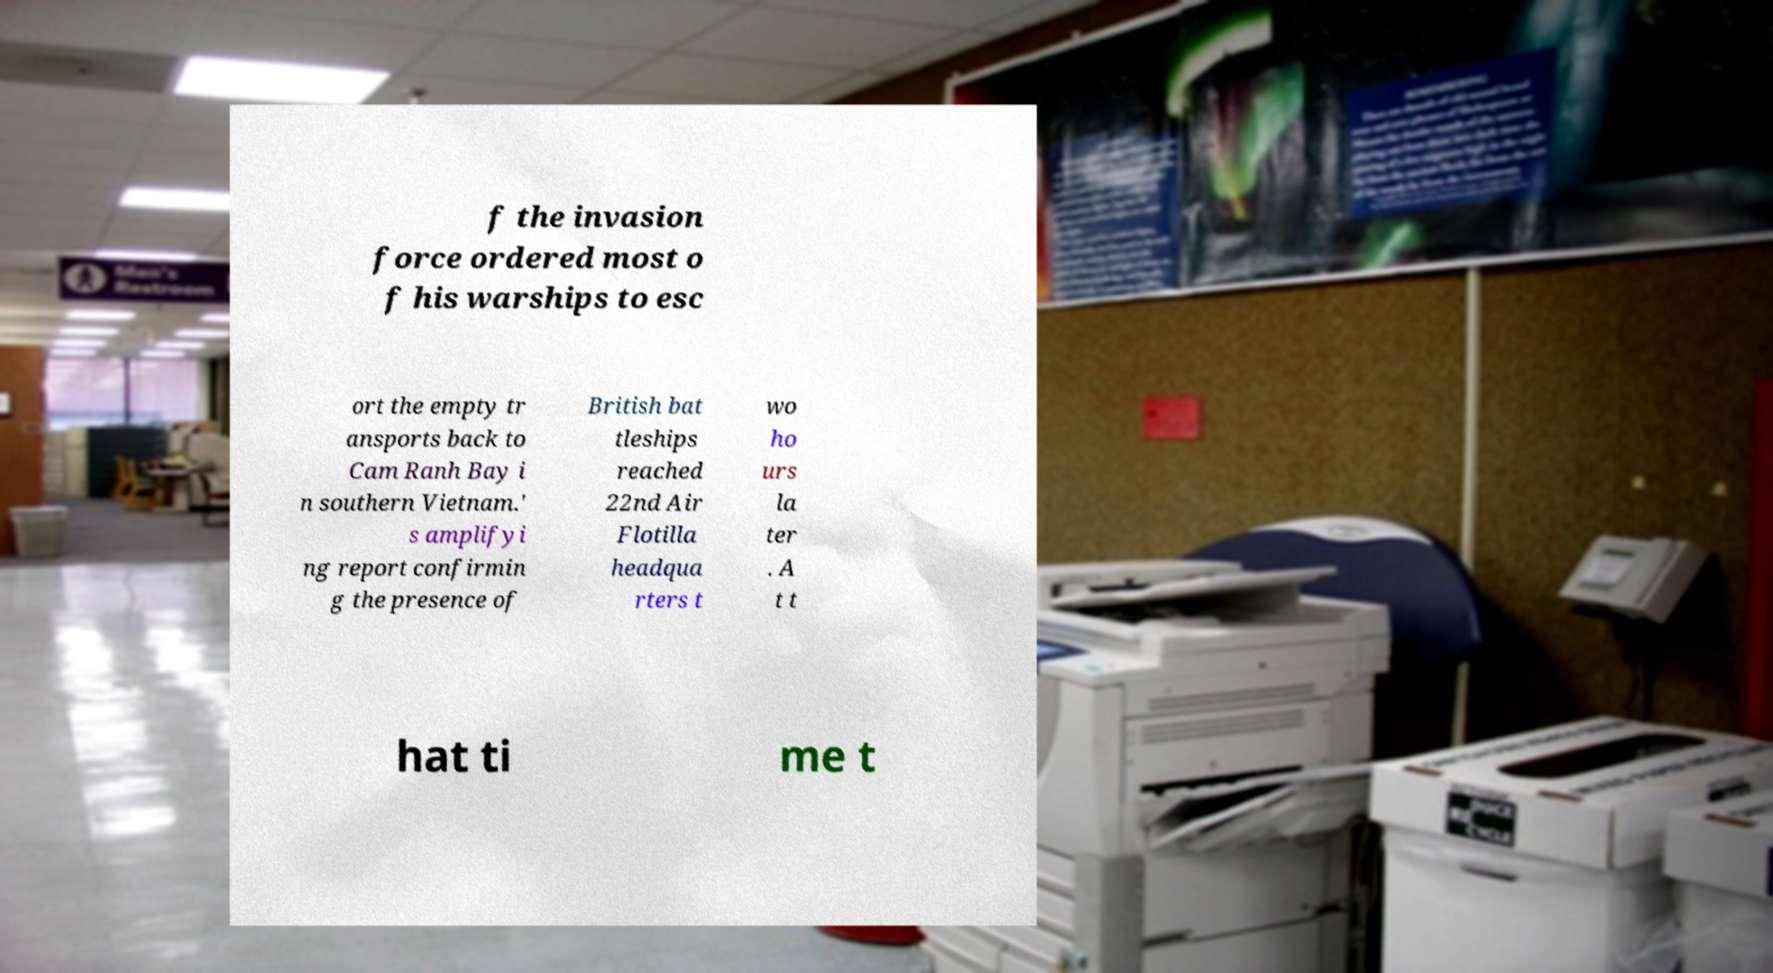Could you extract and type out the text from this image? f the invasion force ordered most o f his warships to esc ort the empty tr ansports back to Cam Ranh Bay i n southern Vietnam.' s amplifyi ng report confirmin g the presence of British bat tleships reached 22nd Air Flotilla headqua rters t wo ho urs la ter . A t t hat ti me t 